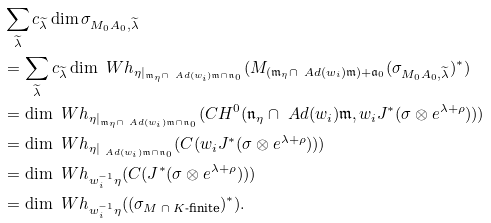Convert formula to latex. <formula><loc_0><loc_0><loc_500><loc_500>& \sum _ { \widetilde { \lambda } } c _ { \widetilde { \lambda } } \dim \sigma _ { M _ { 0 } A _ { 0 } , \widetilde { \lambda } } \\ & = \sum _ { \widetilde { \lambda } } c _ { \widetilde { \lambda } } \dim \ W h _ { \eta | _ { \mathfrak { m } _ { \eta } \cap \ A d ( w _ { i } ) \mathfrak { m } \cap \mathfrak { n } _ { 0 } } } ( M _ { ( \mathfrak { m } _ { \eta } \cap \ A d ( w _ { i } ) \mathfrak { m } ) + \mathfrak { a } _ { 0 } } ( \sigma _ { M _ { 0 } A _ { 0 } , \widetilde { \lambda } } ) ^ { * } ) \\ & = \dim \ W h _ { \eta | _ { \mathfrak { m } _ { \eta } \cap \ A d ( w _ { i } ) \mathfrak { m } \cap \mathfrak { n } _ { 0 } } } ( C H ^ { 0 } ( \mathfrak { n } _ { \eta } \cap \ A d ( w _ { i } ) \mathfrak { m } , w _ { i } J ^ { * } ( \sigma \otimes e ^ { \lambda + \rho } ) ) ) \\ & = \dim \ W h _ { \eta | _ { \ A d ( w _ { i } ) \mathfrak { m } \cap \mathfrak { n } _ { 0 } } } ( C ( w _ { i } J ^ { * } ( \sigma \otimes e ^ { \lambda + \rho } ) ) ) \\ & = \dim \ W h _ { w _ { i } ^ { - 1 } \eta } ( C ( J ^ { * } ( \sigma \otimes e ^ { \lambda + \rho } ) ) ) \\ & = \dim \ W h _ { w _ { i } ^ { - 1 } \eta } ( ( \sigma _ { \text {$M\cap K$-finite} } ) ^ { * } ) .</formula> 